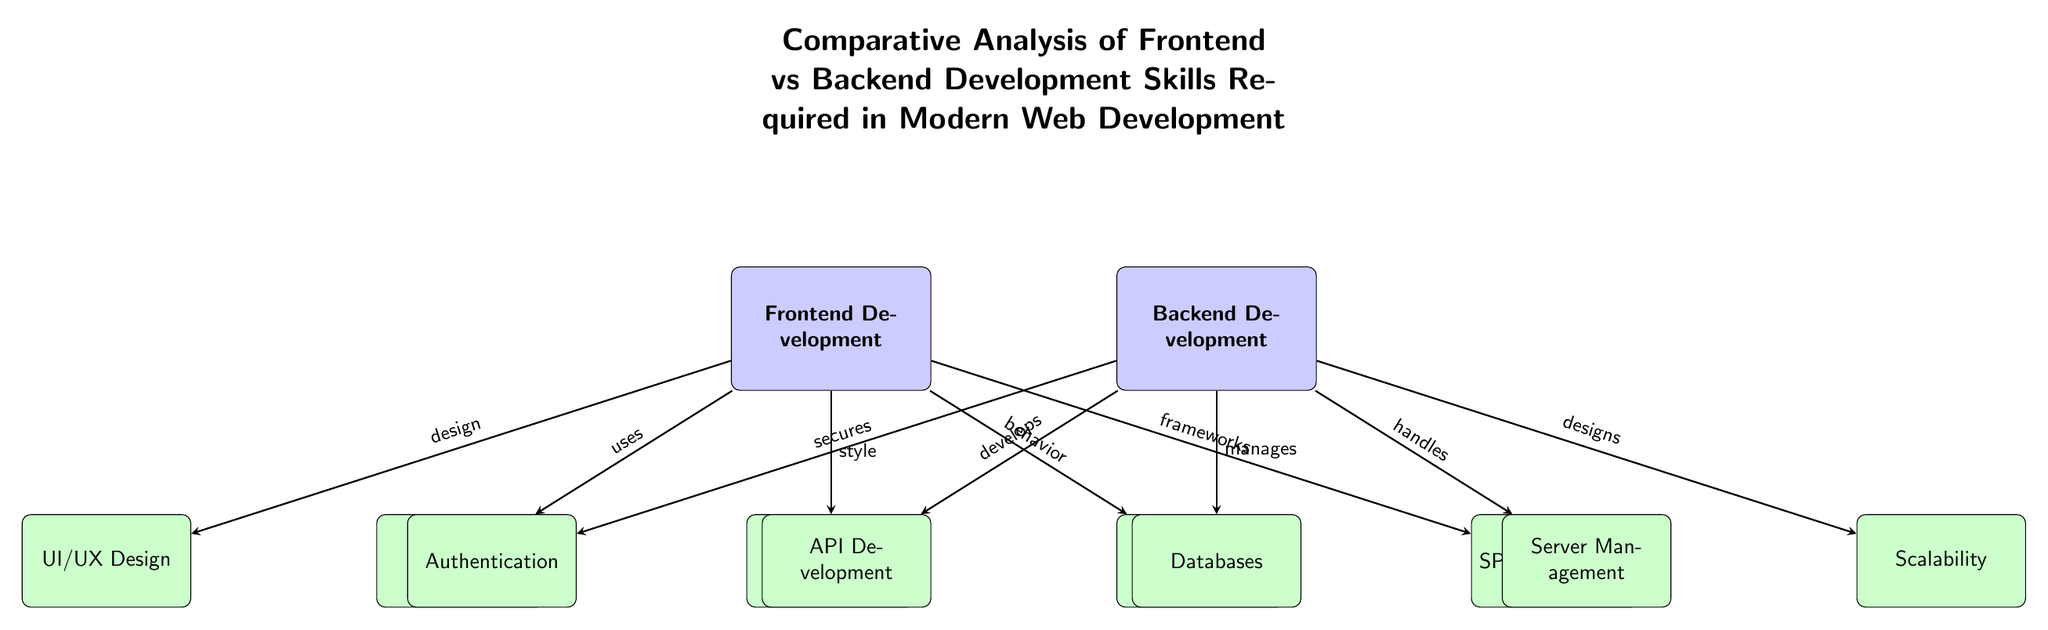What are the two main areas of development highlighted in the diagram? The diagram clearly labels two main nodes representing different areas of development: Frontend Development and Backend Development. These are the primary focus areas depicted at the top level of the diagram.
Answer: Frontend Development, Backend Development How many sub-nodes are associated with Frontend Development? There are a total of five sub-nodes connected to Frontend Development, namely HTML, CSS, JavaScript, UI/UX Design, and SPA Frameworks. This total is counted by visually identifying the sub-nodes positioned below the Frontend node.
Answer: 5 What skill is associated with Backend Development in terms of authentication? The sub-node directly connected to Backend Development regarding authentication is the Authentication node. This node illustrates that part of the backend development involves security measures, specifically authentication practices.
Answer: Authentication Which Frontend skill is specifically focused on behavior? The JavaScript sub-node explicitly linked to the Frontend Development node pertains to behavior, meaning JavaScript is the skill needed to implement dynamic interactions within a web application.
Answer: JavaScript What does Backend Development do with databases? The diagram shows that Backend Development manages Databases, indicating the role of backend developers in handling and organizing data storage for web applications.
Answer: Manages Which node connects the Frontend and Backend Development nodes most closely in terms of functionality? The API Development node connects closely to the Backend Development, indicating that APIs serve as a bridge between the frontend and backend functionalities within web applications. Although not a direct connection from the Frontend node, APIs facilitate communication between the two.
Answer: API Development What design aspect is emphasized within the Frontend Development node? The UI/UX Design node is highlighted as an essential skill under Frontend Development, indicating the importance of user interface and experience design in the frontend development process.
Answer: UI/UX Design What is the relationship between Backend Development and scalability? The Scalability node is marked as part of the Backend Development responsibilities, which means that backend developers are concerned with ensuring that applications can handle increased loads efficiently.
Answer: Designs How are server management skills classified in the diagram? Server Management is classified as a sub-node of Backend Development, signifying its importance as a skill in managing server-side resources and maintaining the infrastructure required for web applications.
Answer: Server Management 